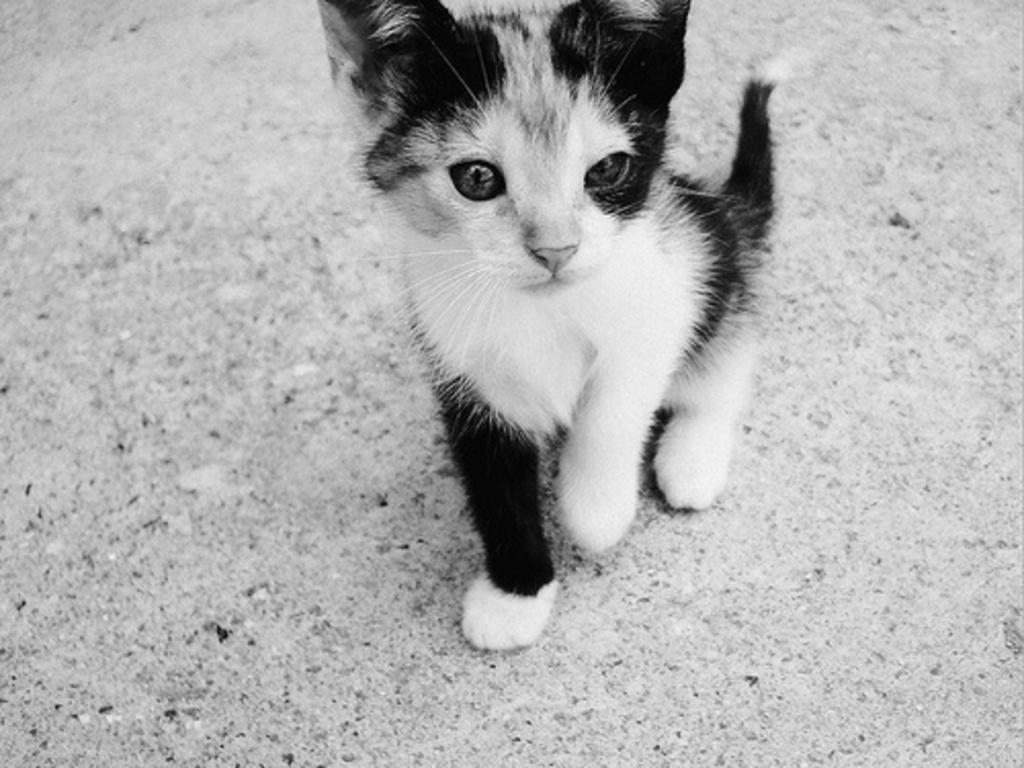How would you summarize this image in a sentence or two? In this picture I can see the cat on the surface. 